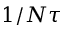<formula> <loc_0><loc_0><loc_500><loc_500>1 / N \tau</formula> 